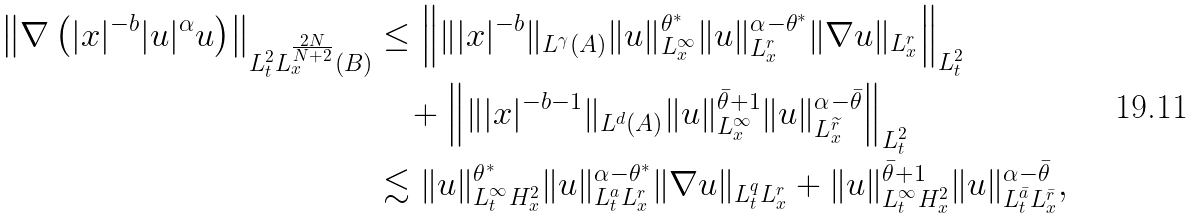<formula> <loc_0><loc_0><loc_500><loc_500>\left \| \nabla \left ( | x | ^ { - b } | u | ^ { \alpha } u \right ) \right \| _ { L ^ { 2 } _ { t } L _ { x } ^ { \frac { 2 N } { N + 2 } } ( B ) } & \leq \left \| \| | x | ^ { - b } \| _ { L ^ { \gamma } ( A ) } \| u \| _ { L _ { x } ^ { \infty } } ^ { \theta ^ { * } } \| u \| _ { L _ { x } ^ { r } } ^ { \alpha - \theta ^ { * } } \| \nabla u \| _ { L ^ { r } _ { x } } \right \| _ { L ^ { 2 } _ { t } } \\ & \quad + \left \| \| | x | ^ { - b - 1 } \| _ { L ^ { d } ( A ) } \| u \| _ { L _ { x } ^ { \infty } } ^ { \bar { \theta } + 1 } \| u \| _ { L _ { x } ^ { \widetilde { r } } } ^ { \alpha - \bar { \theta } } \right \| _ { L ^ { 2 } _ { t } } \\ & \lesssim \| u \| ^ { \theta ^ { * } } _ { L ^ { \infty } _ { t } H _ { x } ^ { 2 } } \| u \| _ { L _ { t } ^ { a } L _ { x } ^ { r } } ^ { \alpha - \theta ^ { * } } \| \nabla u \| _ { L _ { t } ^ { q } L ^ { r } _ { x } } + \| u \| _ { L ^ { \infty } _ { t } H _ { x } ^ { 2 } } ^ { \bar { \theta } + 1 } \| u \| _ { L _ { t } ^ { \bar { a } } L _ { x } ^ { \bar { r } } } ^ { \alpha - \bar { \theta } } ,</formula> 